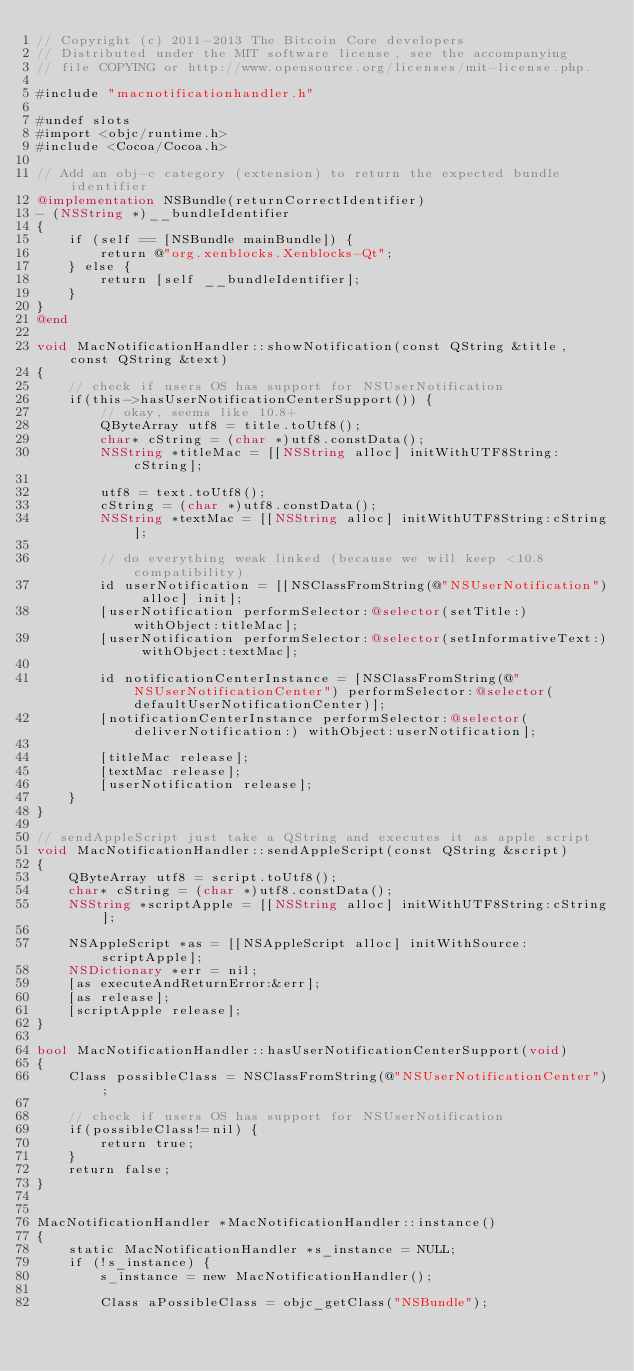Convert code to text. <code><loc_0><loc_0><loc_500><loc_500><_ObjectiveC_>// Copyright (c) 2011-2013 The Bitcoin Core developers
// Distributed under the MIT software license, see the accompanying
// file COPYING or http://www.opensource.org/licenses/mit-license.php.

#include "macnotificationhandler.h"

#undef slots
#import <objc/runtime.h>
#include <Cocoa/Cocoa.h>

// Add an obj-c category (extension) to return the expected bundle identifier
@implementation NSBundle(returnCorrectIdentifier)
- (NSString *)__bundleIdentifier
{
    if (self == [NSBundle mainBundle]) {
        return @"org.xenblocks.Xenblocks-Qt";
    } else {
        return [self __bundleIdentifier];
    }
}
@end

void MacNotificationHandler::showNotification(const QString &title, const QString &text)
{
    // check if users OS has support for NSUserNotification
    if(this->hasUserNotificationCenterSupport()) {
        // okay, seems like 10.8+
        QByteArray utf8 = title.toUtf8();
        char* cString = (char *)utf8.constData();
        NSString *titleMac = [[NSString alloc] initWithUTF8String:cString];

        utf8 = text.toUtf8();
        cString = (char *)utf8.constData();
        NSString *textMac = [[NSString alloc] initWithUTF8String:cString];

        // do everything weak linked (because we will keep <10.8 compatibility)
        id userNotification = [[NSClassFromString(@"NSUserNotification") alloc] init];
        [userNotification performSelector:@selector(setTitle:) withObject:titleMac];
        [userNotification performSelector:@selector(setInformativeText:) withObject:textMac];

        id notificationCenterInstance = [NSClassFromString(@"NSUserNotificationCenter") performSelector:@selector(defaultUserNotificationCenter)];
        [notificationCenterInstance performSelector:@selector(deliverNotification:) withObject:userNotification];

        [titleMac release];
        [textMac release];
        [userNotification release];
    }
}

// sendAppleScript just take a QString and executes it as apple script
void MacNotificationHandler::sendAppleScript(const QString &script)
{
    QByteArray utf8 = script.toUtf8();
    char* cString = (char *)utf8.constData();
    NSString *scriptApple = [[NSString alloc] initWithUTF8String:cString];

    NSAppleScript *as = [[NSAppleScript alloc] initWithSource:scriptApple];
    NSDictionary *err = nil;
    [as executeAndReturnError:&err];
    [as release];
    [scriptApple release];
}

bool MacNotificationHandler::hasUserNotificationCenterSupport(void)
{
    Class possibleClass = NSClassFromString(@"NSUserNotificationCenter");

    // check if users OS has support for NSUserNotification
    if(possibleClass!=nil) {
        return true;
    }
    return false;
}


MacNotificationHandler *MacNotificationHandler::instance()
{
    static MacNotificationHandler *s_instance = NULL;
    if (!s_instance) {
        s_instance = new MacNotificationHandler();

        Class aPossibleClass = objc_getClass("NSBundle");</code> 